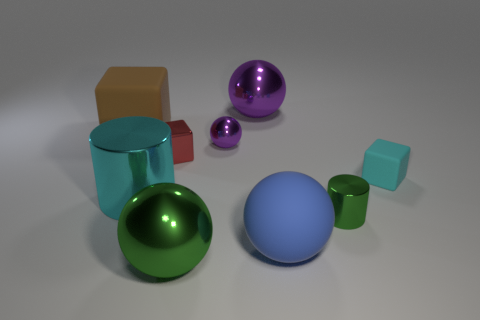Subtract all large green shiny spheres. How many spheres are left? 3 Subtract all cylinders. How many objects are left? 7 Add 8 purple spheres. How many purple spheres exist? 10 Subtract all green cylinders. How many cylinders are left? 1 Subtract 0 gray cylinders. How many objects are left? 9 Subtract 1 cylinders. How many cylinders are left? 1 Subtract all green cubes. Subtract all green spheres. How many cubes are left? 3 Subtract all gray cubes. How many green cylinders are left? 1 Subtract all purple metal objects. Subtract all cyan blocks. How many objects are left? 6 Add 3 brown cubes. How many brown cubes are left? 4 